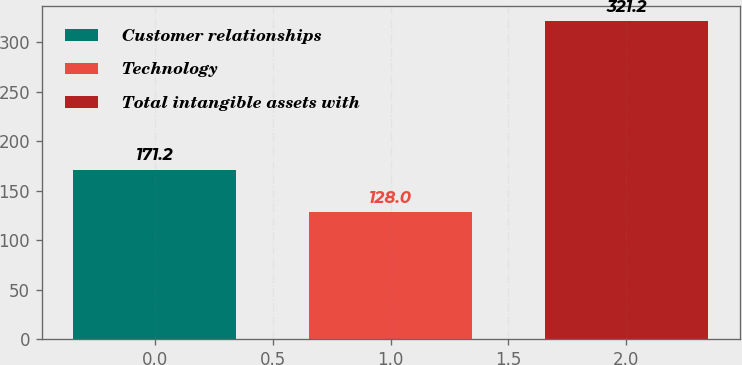<chart> <loc_0><loc_0><loc_500><loc_500><bar_chart><fcel>Customer relationships<fcel>Technology<fcel>Total intangible assets with<nl><fcel>171.2<fcel>128<fcel>321.2<nl></chart> 